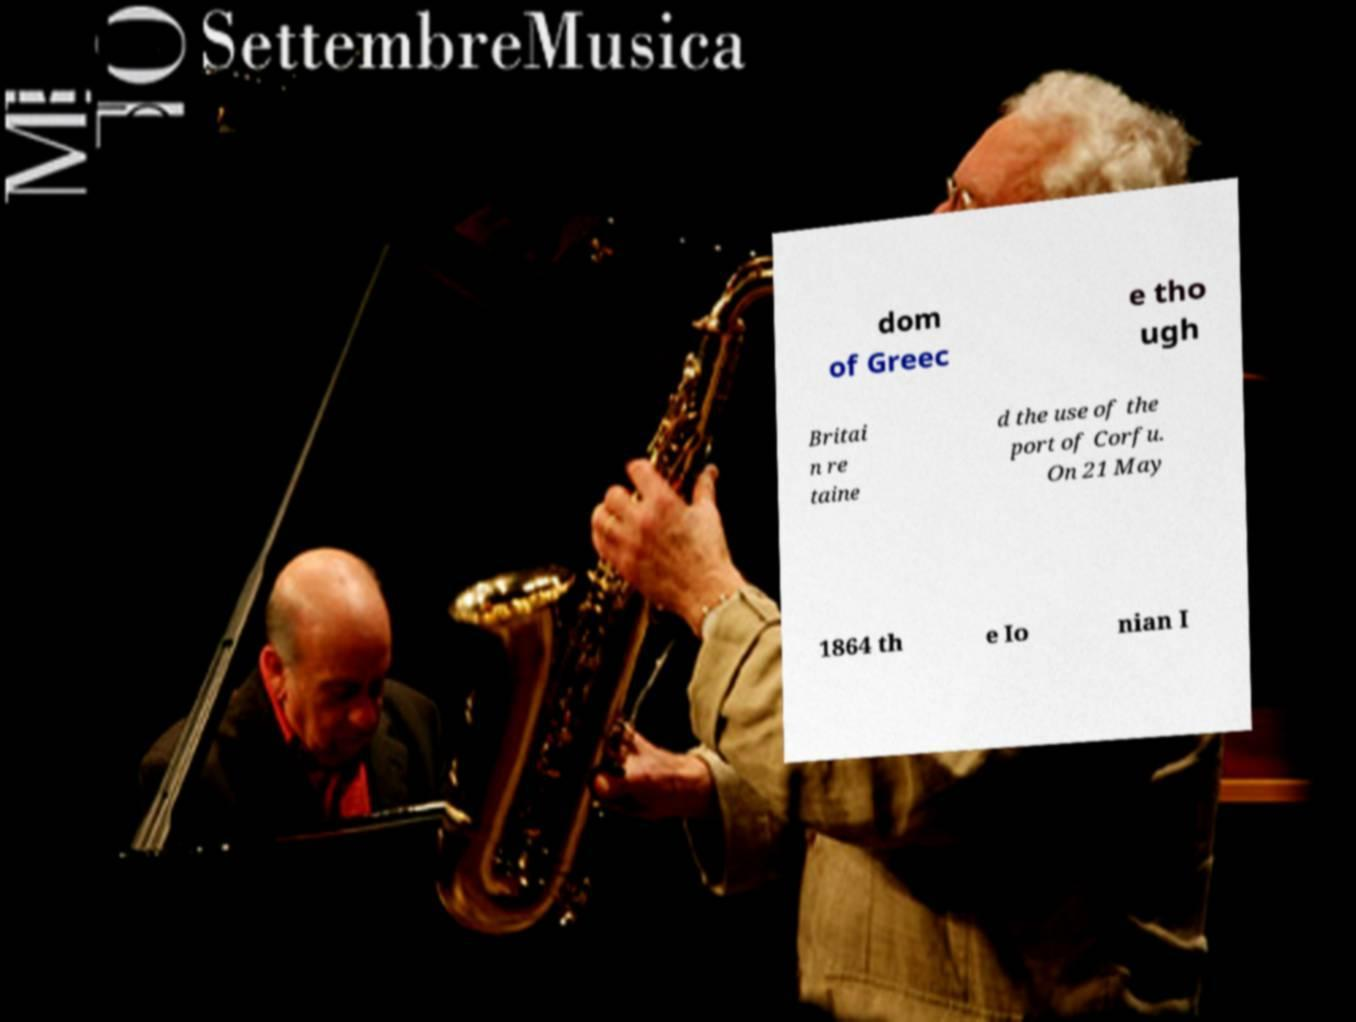What messages or text are displayed in this image? I need them in a readable, typed format. dom of Greec e tho ugh Britai n re taine d the use of the port of Corfu. On 21 May 1864 th e Io nian I 